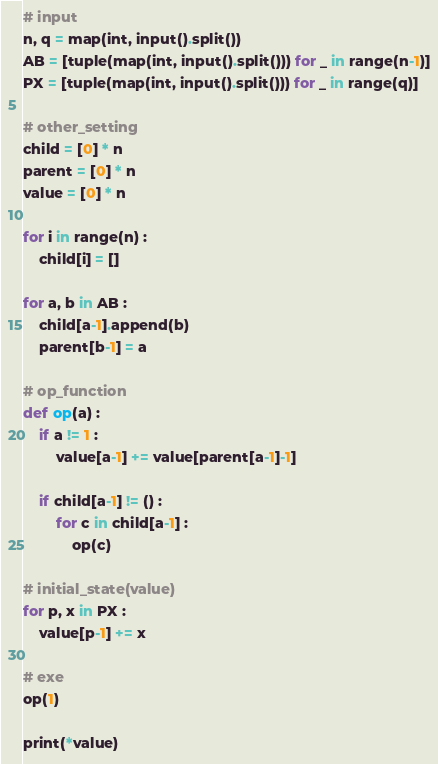<code> <loc_0><loc_0><loc_500><loc_500><_Python_># input
n, q = map(int, input().split())
AB = [tuple(map(int, input().split())) for _ in range(n-1)]
PX = [tuple(map(int, input().split())) for _ in range(q)]

# other_setting
child = [0] * n
parent = [0] * n
value = [0] * n

for i in range(n) : 
    child[i] = []

for a, b in AB : 
    child[a-1].append(b)
    parent[b-1] = a

# op_function
def op(a) : 
    if a != 1 : 
        value[a-1] += value[parent[a-1]-1]

    if child[a-1] != () : 
        for c in child[a-1] : 
            op(c)
            
# initial_state(value)
for p, x in PX : 
    value[p-1] += x
    
# exe
op(1)

print(*value)</code> 